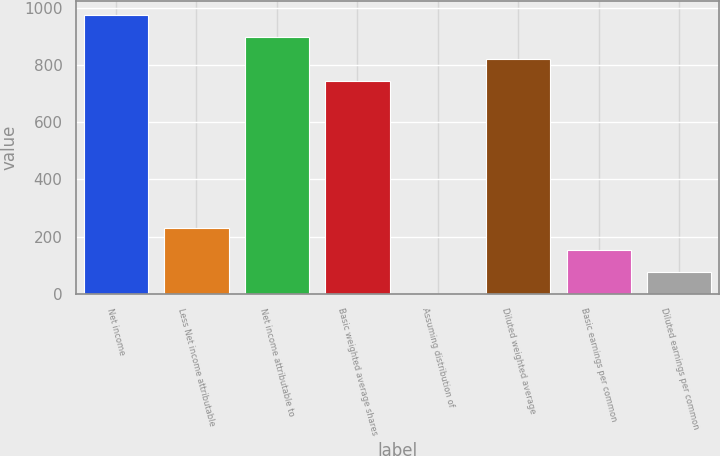<chart> <loc_0><loc_0><loc_500><loc_500><bar_chart><fcel>Net income<fcel>Less Net income attributable<fcel>Net income attributable to<fcel>Basic weighted average shares<fcel>Assuming distribution of<fcel>Diluted weighted average<fcel>Basic earnings per common<fcel>Diluted earnings per common<nl><fcel>974.09<fcel>231.79<fcel>897.06<fcel>743<fcel>0.7<fcel>820.03<fcel>154.76<fcel>77.73<nl></chart> 